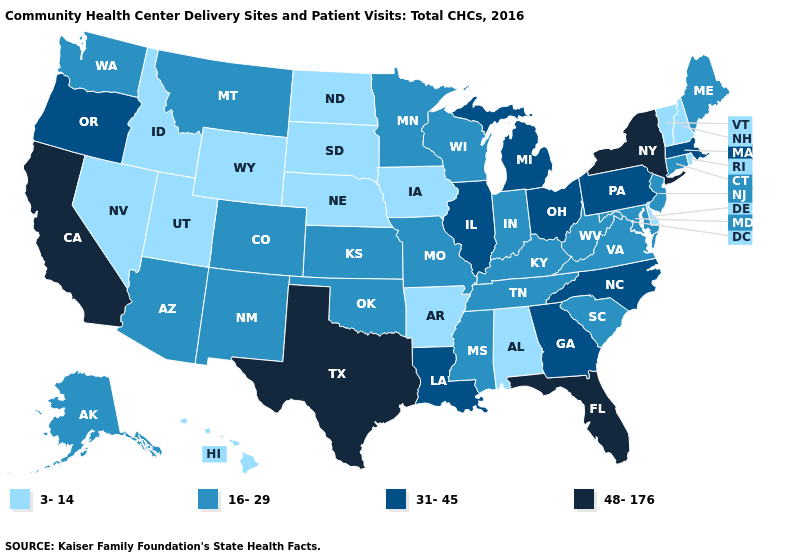What is the value of Maine?
Be succinct. 16-29. Which states have the highest value in the USA?
Write a very short answer. California, Florida, New York, Texas. Does the first symbol in the legend represent the smallest category?
Be succinct. Yes. Among the states that border Wyoming , does Colorado have the highest value?
Keep it brief. Yes. What is the highest value in states that border Massachusetts?
Keep it brief. 48-176. Which states have the lowest value in the South?
Write a very short answer. Alabama, Arkansas, Delaware. What is the value of California?
Write a very short answer. 48-176. What is the lowest value in states that border Nevada?
Concise answer only. 3-14. Which states have the lowest value in the USA?
Short answer required. Alabama, Arkansas, Delaware, Hawaii, Idaho, Iowa, Nebraska, Nevada, New Hampshire, North Dakota, Rhode Island, South Dakota, Utah, Vermont, Wyoming. Does Georgia have a higher value than Alabama?
Short answer required. Yes. Does Indiana have the highest value in the USA?
Answer briefly. No. Name the states that have a value in the range 48-176?
Answer briefly. California, Florida, New York, Texas. Name the states that have a value in the range 16-29?
Answer briefly. Alaska, Arizona, Colorado, Connecticut, Indiana, Kansas, Kentucky, Maine, Maryland, Minnesota, Mississippi, Missouri, Montana, New Jersey, New Mexico, Oklahoma, South Carolina, Tennessee, Virginia, Washington, West Virginia, Wisconsin. What is the highest value in the USA?
Write a very short answer. 48-176. Does Utah have the highest value in the West?
Give a very brief answer. No. 